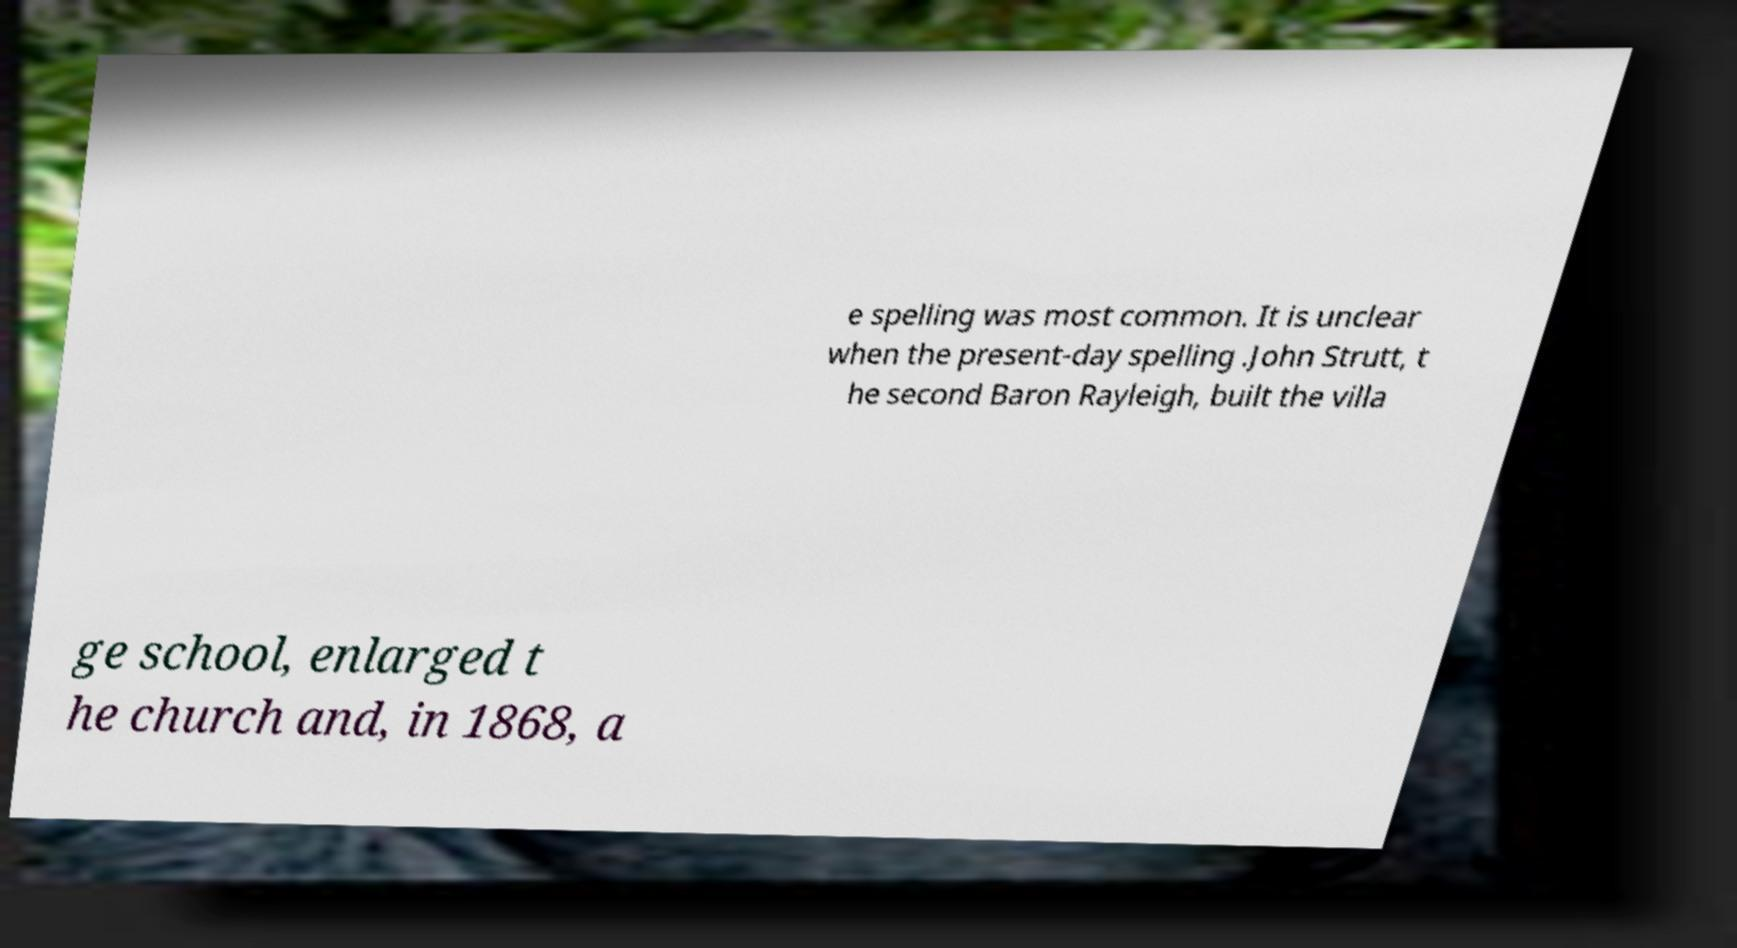Can you accurately transcribe the text from the provided image for me? e spelling was most common. It is unclear when the present-day spelling .John Strutt, t he second Baron Rayleigh, built the villa ge school, enlarged t he church and, in 1868, a 